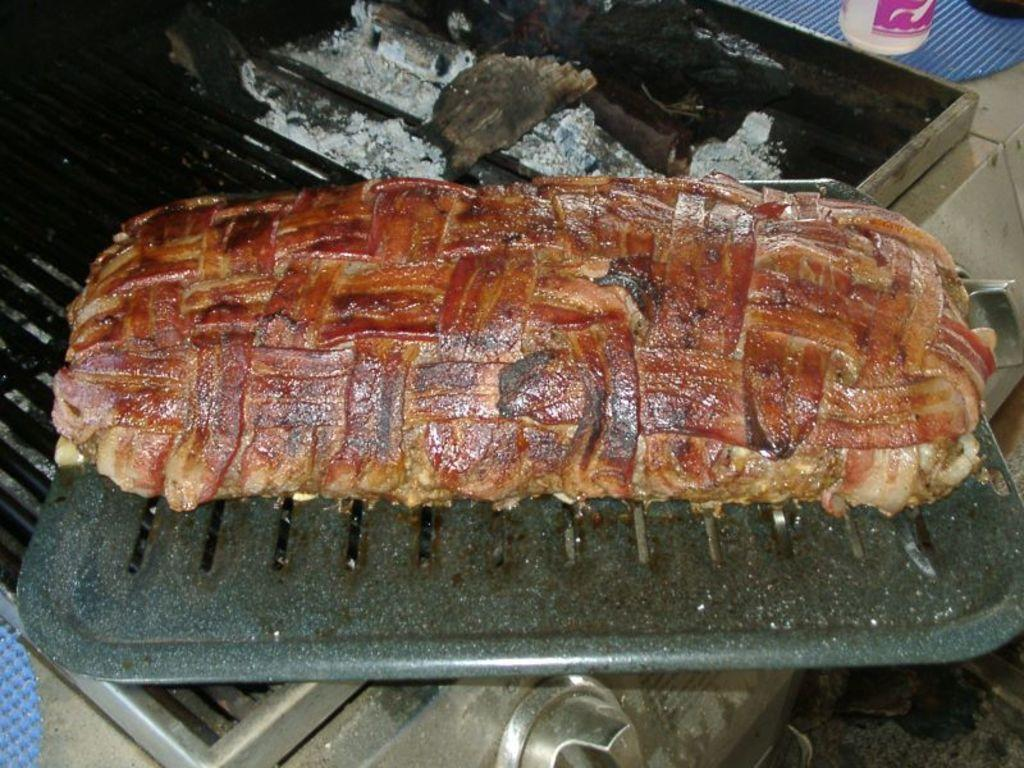What type of food is in the tray that is visible in the image? There is meat in a tray in the image. What else can be seen in the image besides the meat in the tray? There are ashes visible in the image. What type of bread is being weighed on the scale in the image? There is no bread or scale present in the image. What decisions is the committee making in the image? There is no committee or decision-making process depicted in the image. 